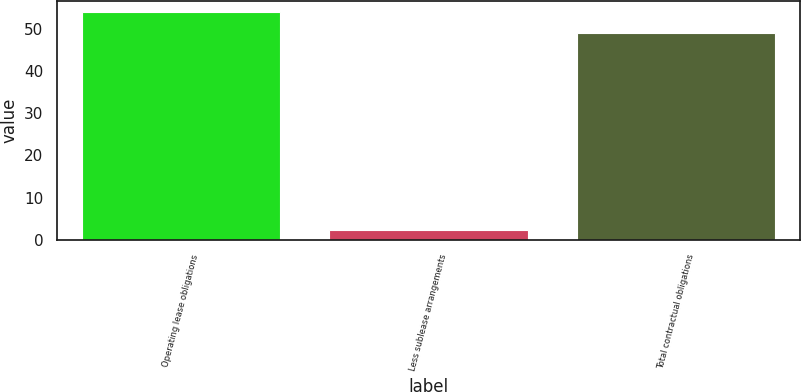Convert chart to OTSL. <chart><loc_0><loc_0><loc_500><loc_500><bar_chart><fcel>Operating lease obligations<fcel>Less sublease arrangements<fcel>Total contractual obligations<nl><fcel>53.95<fcel>2.4<fcel>49.1<nl></chart> 